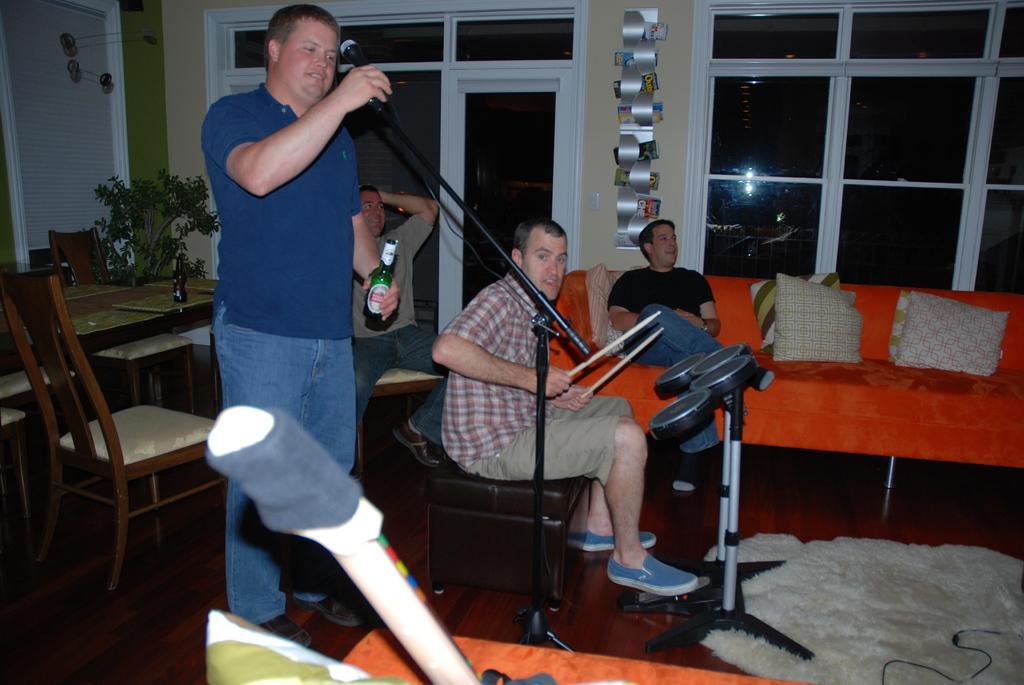In one or two sentences, can you explain what this image depicts? There is a man in this picture holding a bottle in his hand in front of a mic and a stand. There are two persons sitting in the sofas. There are some pillows. And in the background there is a wall and a windows here. 